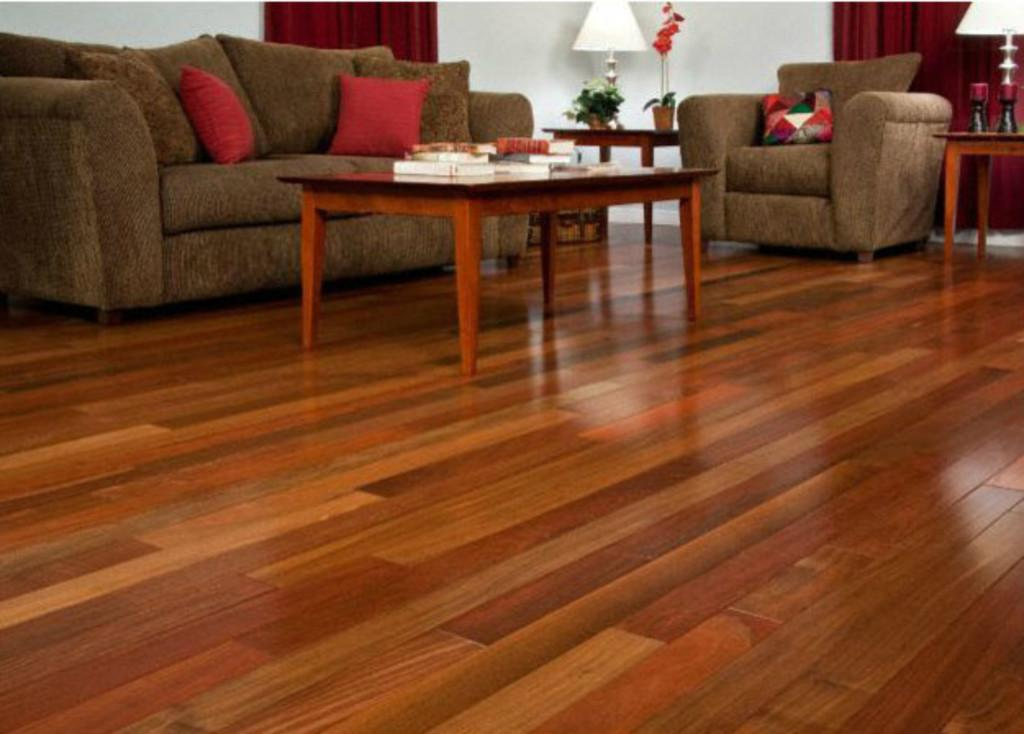What type of furniture is present in the image? There is a table and a couch in the image. What type of lighting is present in the image? There is a lamp in the image. What type of decorative item is present in the image? There is a flower vase in the image. Where is the box of cherries located in the image? There is no box of cherries present in the image. What type of drain is visible in the image? There is no drain present in the image. 